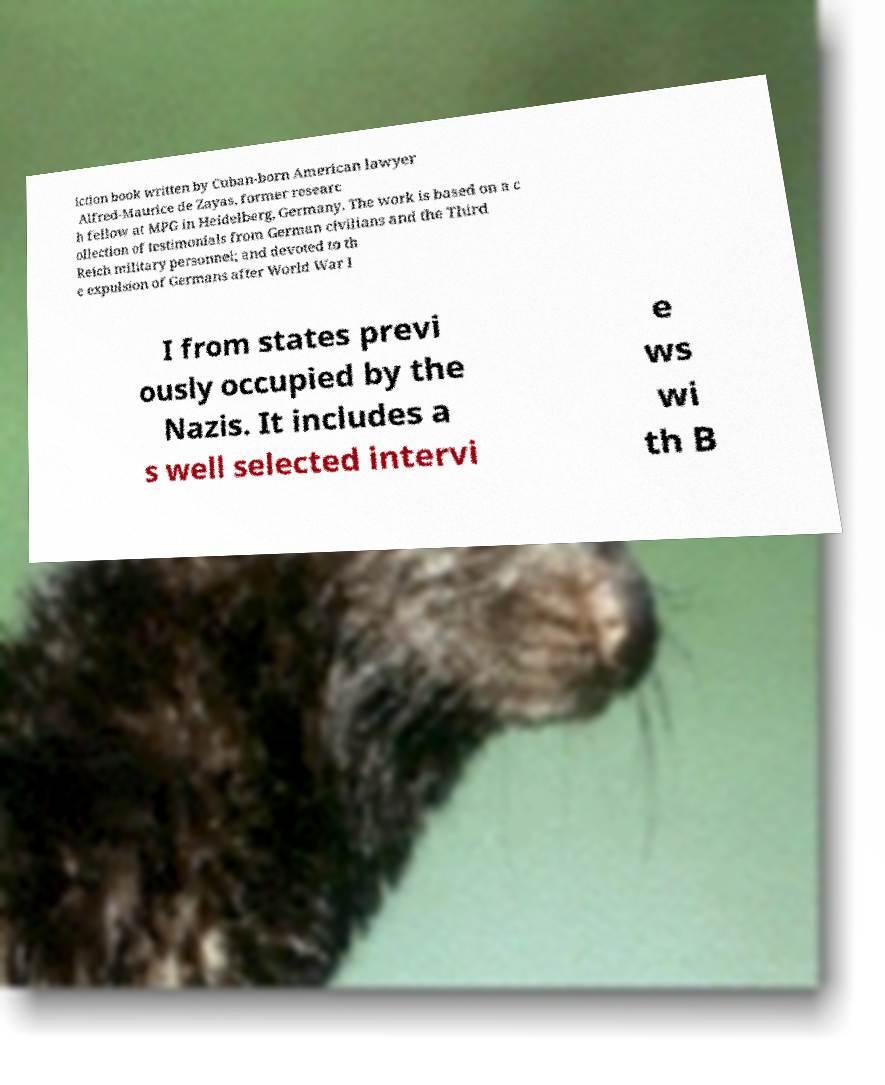Could you extract and type out the text from this image? iction book written by Cuban-born American lawyer Alfred-Maurice de Zayas, former researc h fellow at MPG in Heidelberg, Germany. The work is based on a c ollection of testimonials from German civilians and the Third Reich military personnel; and devoted to th e expulsion of Germans after World War I I from states previ ously occupied by the Nazis. It includes a s well selected intervi e ws wi th B 